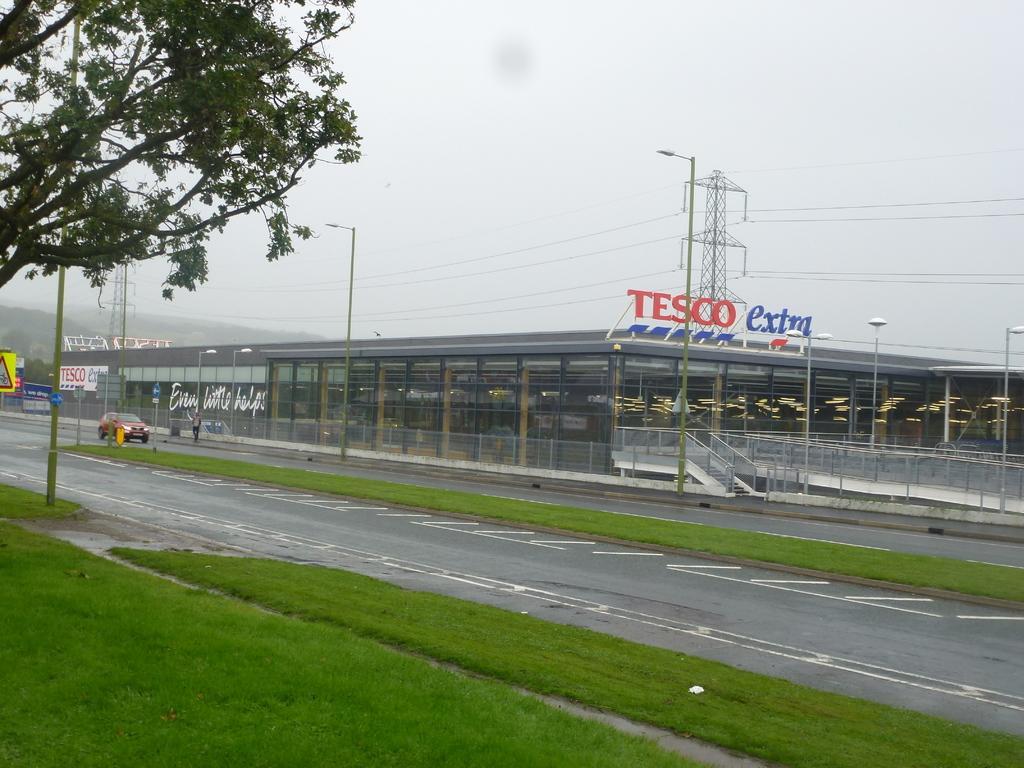In one or two sentences, can you explain what this image depicts? In front of the image there is grass on the surface. In front of the grass there is a road. On the road there are some vehicles passing, beside the road there is a person on the pavement and there are lamp posts, behind the lamp posts there is a supermarket with name board on it. In front of the supermarket there are lamp posts, behind the supermarket there are electric towers with cables on it. In the background of the image there are mountains, on the left of the image there is a sign board and a tree. 